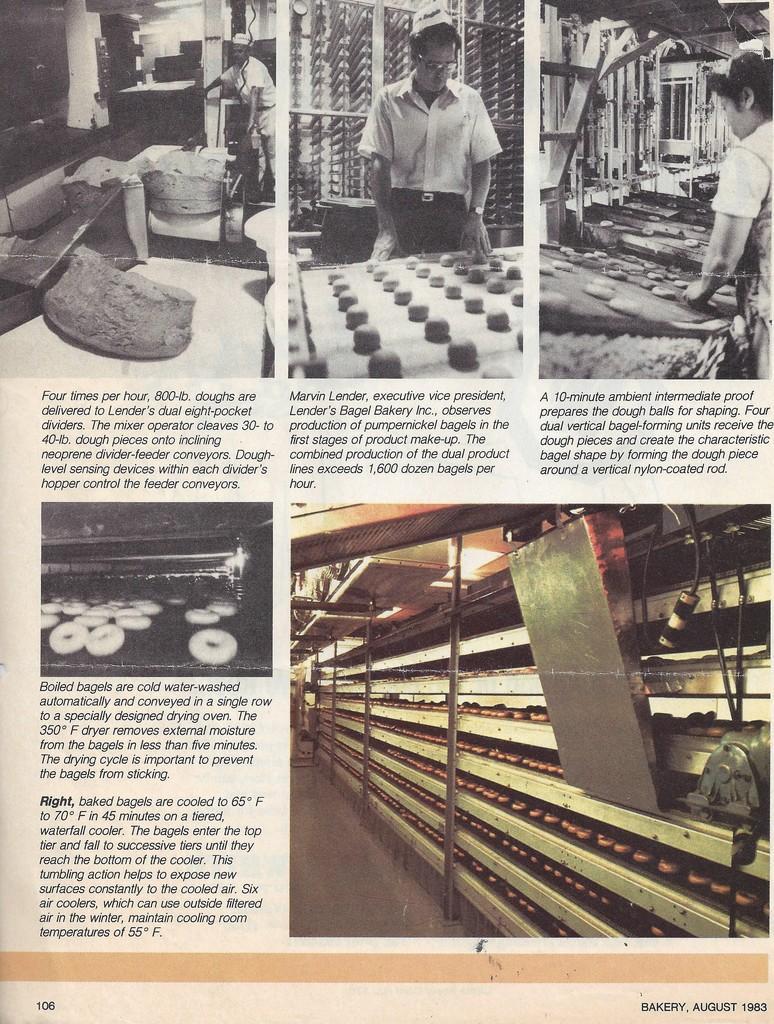Describe this image in one or two sentences. In this picture we can see a newspaper. 